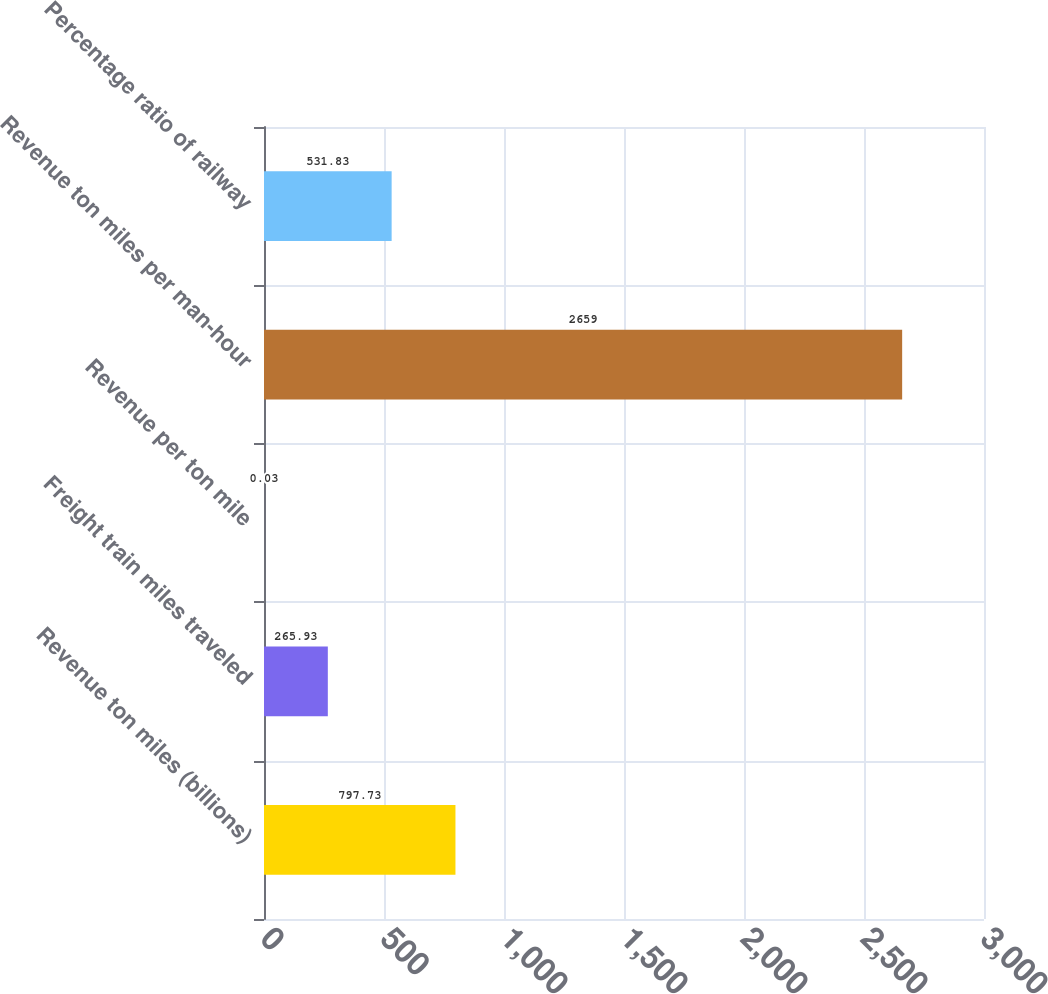<chart> <loc_0><loc_0><loc_500><loc_500><bar_chart><fcel>Revenue ton miles (billions)<fcel>Freight train miles traveled<fcel>Revenue per ton mile<fcel>Revenue ton miles per man-hour<fcel>Percentage ratio of railway<nl><fcel>797.73<fcel>265.93<fcel>0.03<fcel>2659<fcel>531.83<nl></chart> 